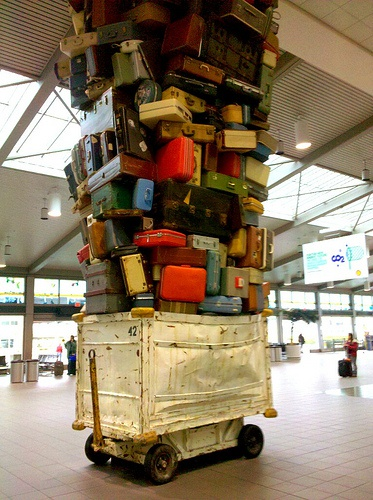Describe the objects in this image and their specific colors. I can see suitcase in olive, black, maroon, and gray tones, suitcase in olive, black, and maroon tones, suitcase in olive, black, maroon, and tan tones, suitcase in olive, red, brown, and maroon tones, and suitcase in olive, brown, maroon, red, and black tones in this image. 